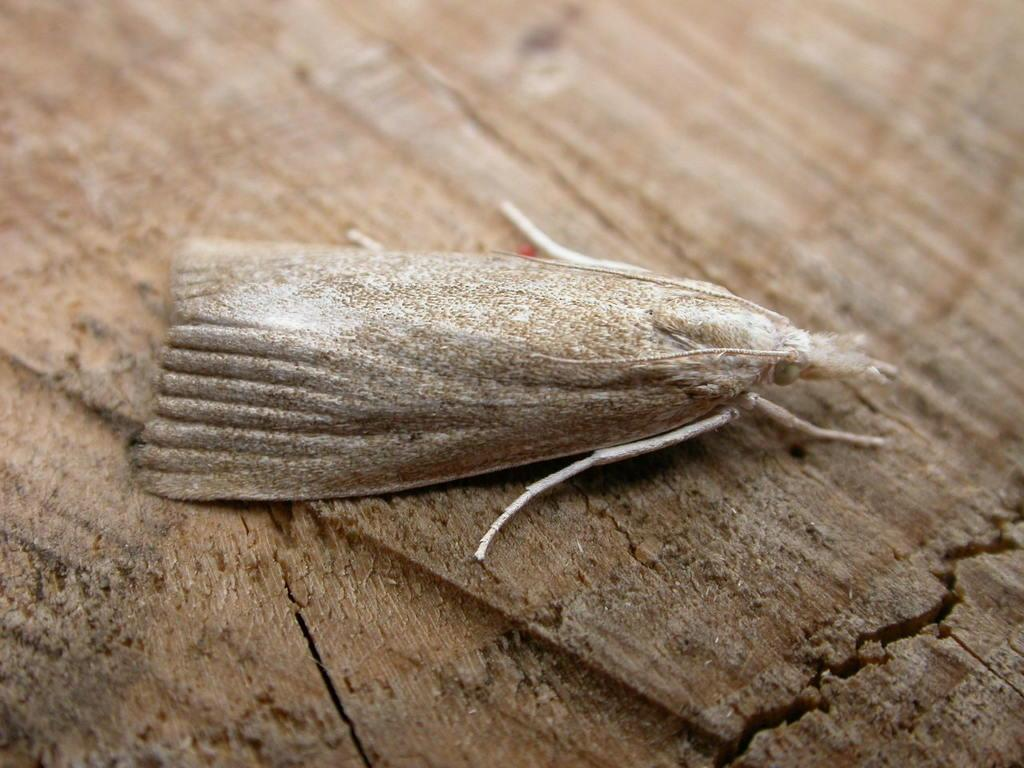What type of creature can be seen in the image? There is an insect in the image. Where is the insect located? The insect is on a wooden floor. What is the plot of the story involving the insect in the image? There is no story or plot present in the image, as it is a static photograph of an insect on a wooden floor. 